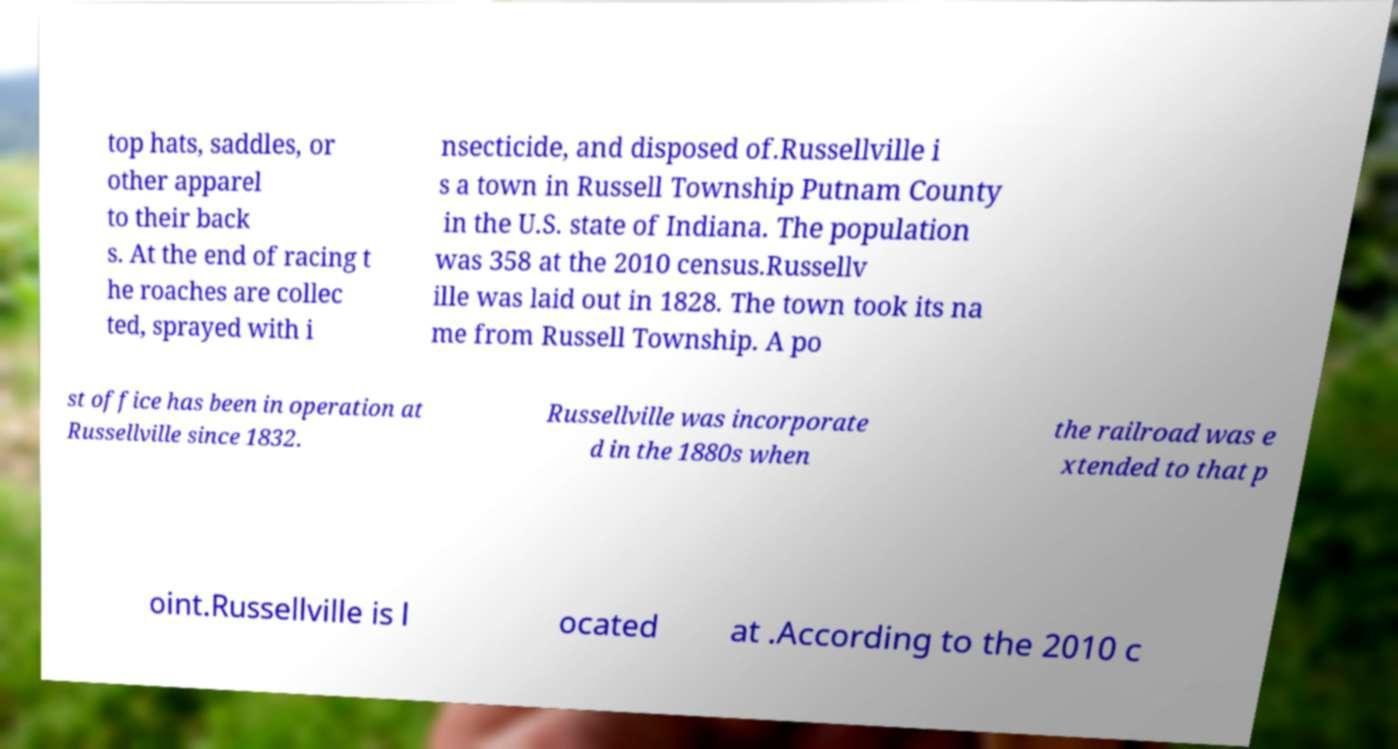Can you read and provide the text displayed in the image?This photo seems to have some interesting text. Can you extract and type it out for me? top hats, saddles, or other apparel to their back s. At the end of racing t he roaches are collec ted, sprayed with i nsecticide, and disposed of.Russellville i s a town in Russell Township Putnam County in the U.S. state of Indiana. The population was 358 at the 2010 census.Russellv ille was laid out in 1828. The town took its na me from Russell Township. A po st office has been in operation at Russellville since 1832. Russellville was incorporate d in the 1880s when the railroad was e xtended to that p oint.Russellville is l ocated at .According to the 2010 c 